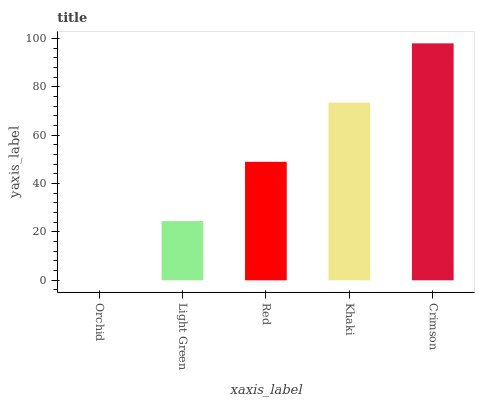Is Orchid the minimum?
Answer yes or no. Yes. Is Crimson the maximum?
Answer yes or no. Yes. Is Light Green the minimum?
Answer yes or no. No. Is Light Green the maximum?
Answer yes or no. No. Is Light Green greater than Orchid?
Answer yes or no. Yes. Is Orchid less than Light Green?
Answer yes or no. Yes. Is Orchid greater than Light Green?
Answer yes or no. No. Is Light Green less than Orchid?
Answer yes or no. No. Is Red the high median?
Answer yes or no. Yes. Is Red the low median?
Answer yes or no. Yes. Is Khaki the high median?
Answer yes or no. No. Is Khaki the low median?
Answer yes or no. No. 